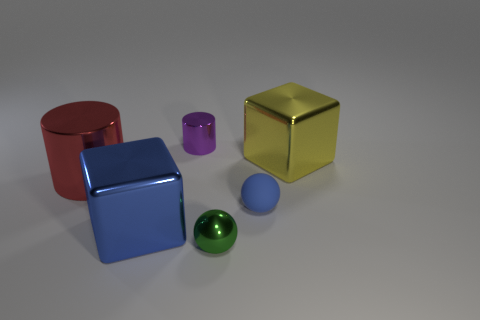What number of other objects are the same color as the matte ball?
Provide a succinct answer. 1. How many brown things are large metallic cubes or small metallic balls?
Provide a succinct answer. 0. There is a big cube that is in front of the shiny cube right of the small blue object; is there a small thing on the right side of it?
Offer a very short reply. Yes. Is there any other thing that has the same size as the matte object?
Ensure brevity in your answer.  Yes. What color is the big metallic cube that is to the left of the small metallic object that is in front of the small blue sphere?
Make the answer very short. Blue. How many big things are either metallic spheres or brown metallic things?
Provide a short and direct response. 0. The small thing that is behind the tiny green metal object and in front of the big yellow cube is what color?
Your response must be concise. Blue. Are the green ball and the large yellow cube made of the same material?
Keep it short and to the point. Yes. The big blue thing has what shape?
Give a very brief answer. Cube. What number of small objects are in front of the big cube that is behind the sphere behind the big blue metal thing?
Provide a succinct answer. 2. 